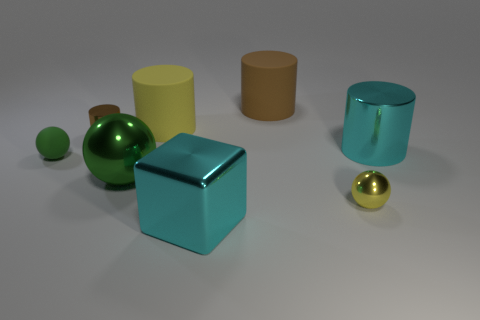What number of big balls are the same color as the tiny matte object?
Make the answer very short. 1. What number of cylinders are right of the brown object that is on the left side of the cyan metallic object that is left of the large cyan cylinder?
Offer a terse response. 3. The small rubber ball is what color?
Offer a terse response. Green. How many other objects are there of the same size as the cyan metallic cylinder?
Offer a very short reply. 4. There is a large object that is the same shape as the small green rubber object; what is it made of?
Provide a succinct answer. Metal. What material is the ball that is on the right side of the brown object that is to the right of the large cyan metal object that is to the left of the large shiny cylinder?
Offer a terse response. Metal. There is a cyan cube that is the same material as the large sphere; what size is it?
Make the answer very short. Large. Are there any other things of the same color as the small rubber thing?
Keep it short and to the point. Yes. There is a small sphere on the left side of the small yellow metal thing; is its color the same as the tiny metallic thing that is on the right side of the brown metal cylinder?
Provide a succinct answer. No. There is a big matte thing right of the large cyan shiny cube; what is its color?
Offer a terse response. Brown. 